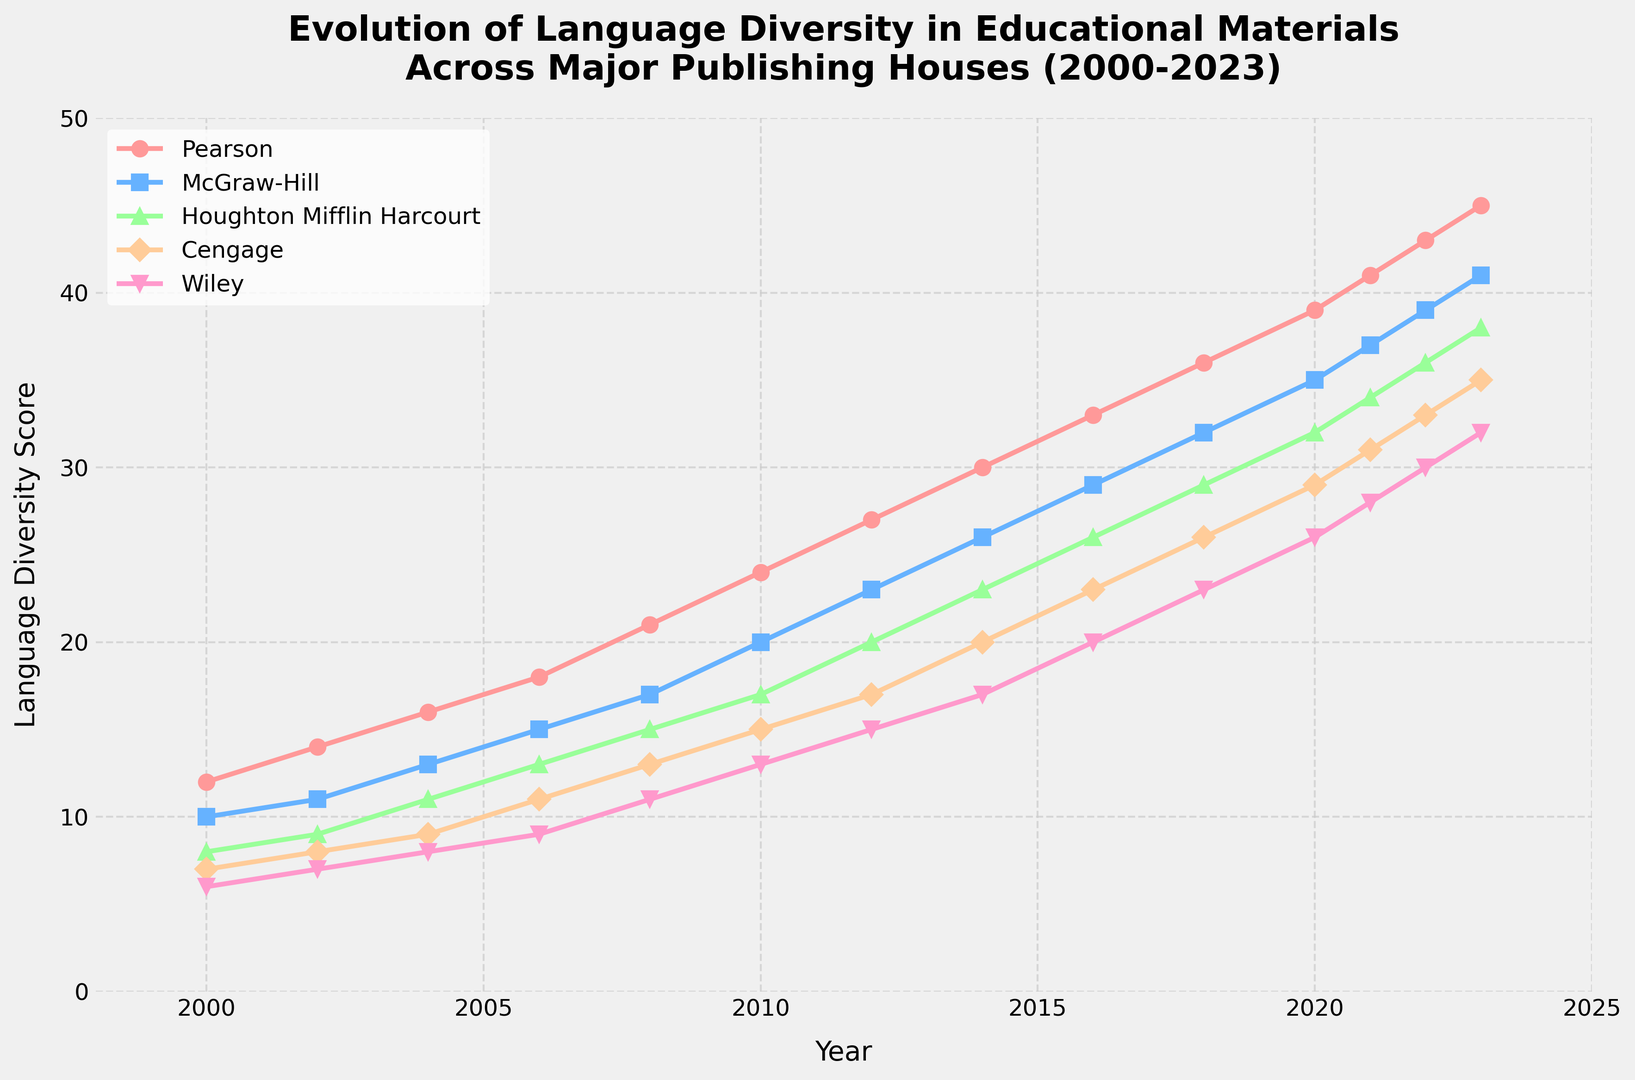What trend is observed for Pearson from 2000 to 2023? Observe the line representing Pearson in the plot. The line shows a consistent upward trend from 12 in 2000 to 45 in 2023, indicating an increase in language diversity over the years.
Answer: Upward trend Which publishing house shows the greatest increase in language diversity from 2000 to 2023? Calculate the difference in language diversity scores for each publishing house between 2000 and 2023. Pearson increased from 12 to 45 (33), McGraw-Hill from 10 to 41 (31), Houghton Mifflin Harcourt from 8 to 38 (30), Cengage from 7 to 35 (28), and Wiley from 6 to 32 (26).
Answer: Pearson In which years does Wiley achieve a language diversity score of 20 or higher? Follow the line representing Wiley and identify the years where the score is 20 or higher. Wiley reaches 20 in 2016 and continues to rise in subsequent years.
Answer: 2016, 2018, 2020, 2021, 2022, 2023 At what year does McGraw-Hill surpass a language diversity score of 30? Locate the specific point where McGraw-Hill's line crosses the score of 30. This occurs between 2016 and 2018, precisely in 2018.
Answer: 2018 Who had a higher language diversity score in 2010, Cengage or Houghton Mifflin Harcourt, and by how much? Compare the values for Cengage and Houghton Mifflin Harcourt in 2010. Cengage has a score of 15 while Houghton Mifflin Harcourt has 17. The difference is 17 - 15 = 2.
Answer: Houghton Mifflin Harcourt by 2 points What is the average language diversity score for all publishing houses in 2022? Sum the scores for all publishing houses in 2022 and divide by the number of houses: (43 + 39 + 36 + 33 + 30) / 5 = 36.2.
Answer: 36.2 When did Cengage first reach a language diversity score above 10? Trace the line for Cengage and find the year it first surpassed 10. The plot shows it happens between 2004 and 2006, precisely in 2006.
Answer: 2006 Which publishing houses had the same language diversity score at any point between 2000 and 2023? Follow and compare curves across the years. McGraw-Hill shared the score of 20 with Cengage in 2010, and Cengage shared 17 with Houghton Mifflin Harcourt in 2010.
Answer: McGraw-Hill and Cengage (2010), Cengage and Houghton Mifflin Harcourt (2010) Based on the visual attributes, which company's diversity curve is represented with a green color, and what is the trend? Identify the line colored green, which corresponds to Houghton Mifflin Harcourt. It shows a consistent upward trend from 8 in 2000 to 38 in 2023.
Answer: Houghton Mifflin Harcourt, upward trend 